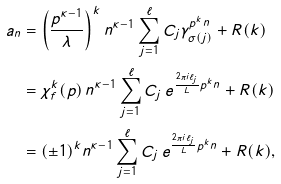Convert formula to latex. <formula><loc_0><loc_0><loc_500><loc_500>a _ { n } & = \left ( \frac { p ^ { \kappa - 1 } } { \lambda } \right ) ^ { k } n ^ { \kappa - 1 } \sum _ { j = 1 } ^ { \ell } C _ { j } \gamma _ { \sigma ( j ) } ^ { p ^ { k } n } + R ( k ) \\ & = \chi ^ { k } _ { f } ( p ) \, n ^ { \kappa - 1 } \sum _ { j = 1 } ^ { \ell } C _ { j } \, e ^ { \frac { 2 \pi i \ell _ { j } } { L } p ^ { k } n } + R ( k ) \\ & = ( \pm 1 ) ^ { k } n ^ { \kappa - 1 } \sum _ { j = 1 } ^ { \ell } C _ { j } \, e ^ { \frac { 2 \pi i \ell _ { j } } { L } p ^ { k } n } + R ( k ) ,</formula> 